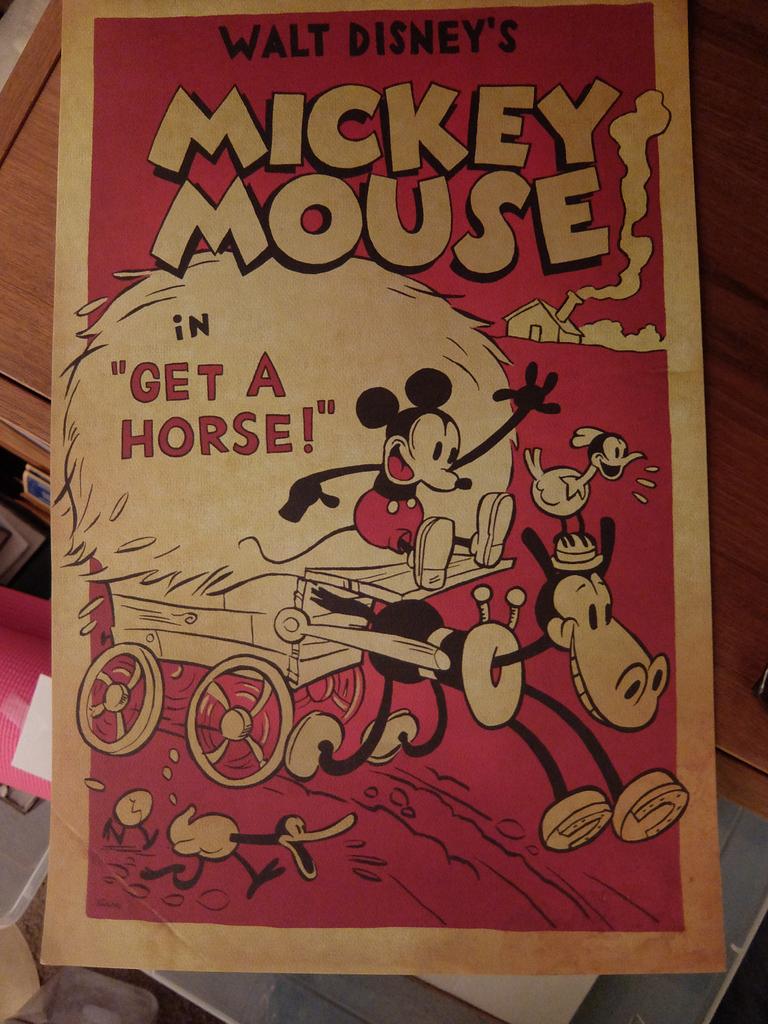What famous mouse is drawn here?
Your answer should be compact. Mickey mouse. What is mickey mouse saying?
Offer a very short reply. Get a horse. 